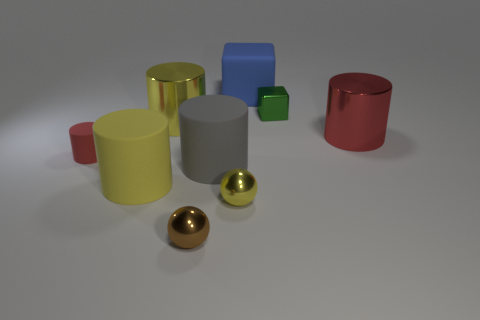Subtract 3 cylinders. How many cylinders are left? 2 Subtract all tiny cylinders. How many cylinders are left? 4 Subtract all gray cylinders. How many cylinders are left? 4 Add 1 blue shiny things. How many objects exist? 10 Subtract all blue cylinders. Subtract all yellow spheres. How many cylinders are left? 5 Subtract all blocks. How many objects are left? 7 Add 7 tiny shiny blocks. How many tiny shiny blocks exist? 8 Subtract 1 brown spheres. How many objects are left? 8 Subtract all blue matte balls. Subtract all tiny brown metal balls. How many objects are left? 8 Add 8 large yellow objects. How many large yellow objects are left? 10 